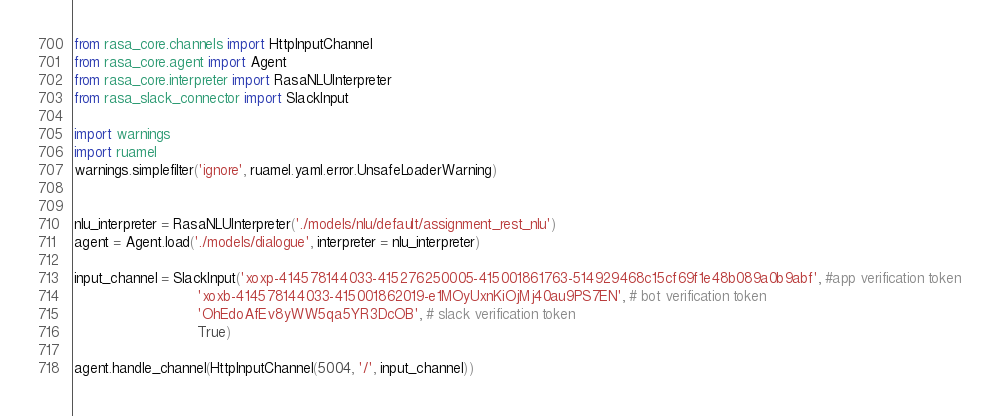Convert code to text. <code><loc_0><loc_0><loc_500><loc_500><_Python_>from rasa_core.channels import HttpInputChannel
from rasa_core.agent import Agent
from rasa_core.interpreter import RasaNLUInterpreter
from rasa_slack_connector import SlackInput

import warnings
import ruamel
warnings.simplefilter('ignore', ruamel.yaml.error.UnsafeLoaderWarning)


nlu_interpreter = RasaNLUInterpreter('./models/nlu/default/assignment_rest_nlu')
agent = Agent.load('./models/dialogue', interpreter = nlu_interpreter)

input_channel = SlackInput('xoxp-414578144033-415276250005-415001861763-514929468c15cf69f1e48b089a0b9abf', #app verification token
							'xoxb-414578144033-415001862019-e1MOyUxnKiOjMj40au9PS7EN', # bot verification token
							'OhEdoAfEv8yWW5qa5YR3DcOB', # slack verification token
							True)

agent.handle_channel(HttpInputChannel(5004, '/', input_channel))</code> 